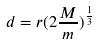Convert formula to latex. <formula><loc_0><loc_0><loc_500><loc_500>d = r ( 2 \frac { M } { m } ) ^ { \frac { 1 } { 3 } }</formula> 